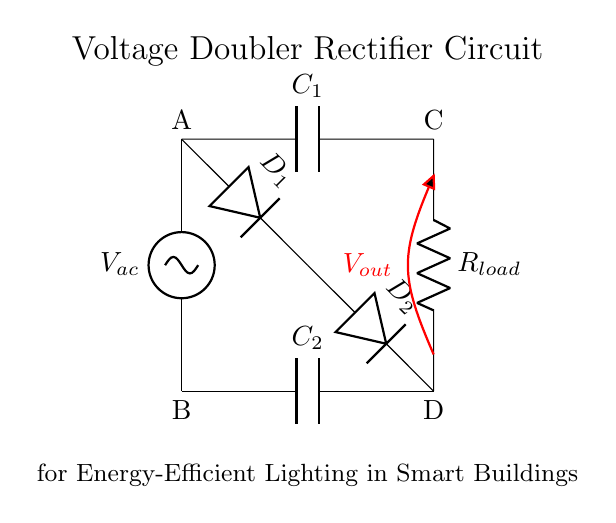What type of circuit is shown? The circuit is a voltage doubler rectifier circuit, which involves both diodes and capacitors working together to increase the output voltage from an alternating current source.
Answer: Voltage doubler rectifier What components are used in this circuit? The circuit consists of two diodes, two capacitors, and one load resistor. The components work together to convert AC voltage into a higher DC voltage.
Answer: Diodes, capacitors, load resistor What is the purpose of the capacitors in this circuit? The capacitors in the circuit are used to store charge temporarily and help smooth the output voltage by reducing voltage ripples, while also enabling the voltage doubling effect when charged and discharged in tandem with the diodes.
Answer: Charge storage How many diodes are present in the circuit? By examining the circuit, we can see that there are two diodes (D1 and D2) which are crucial for allowing current to flow in one direction, making the rectification possible.
Answer: Two What does the output voltage represent? The output voltage (Vout) represents the boosted voltage level after the rectification process, indicating that the circuit effectively doubles the input peak voltage during its operation, suitable for energy-efficient applications.
Answer: Vout Why is this circuit beneficial for smart buildings? This circuit is beneficial for smart buildings as it efficiently converts and boosts AC voltage to power energy-efficient lighting systems, thereby reducing energy consumption and enhancing sustainability.
Answer: Energy efficiency What direction do the diodes allow current to flow? The diodes allow current to flow in one specific direction, which is essential for converting AC to DC, ensuring that current only passes through during the positive half-cycles of the AC waveform.
Answer: One direction 